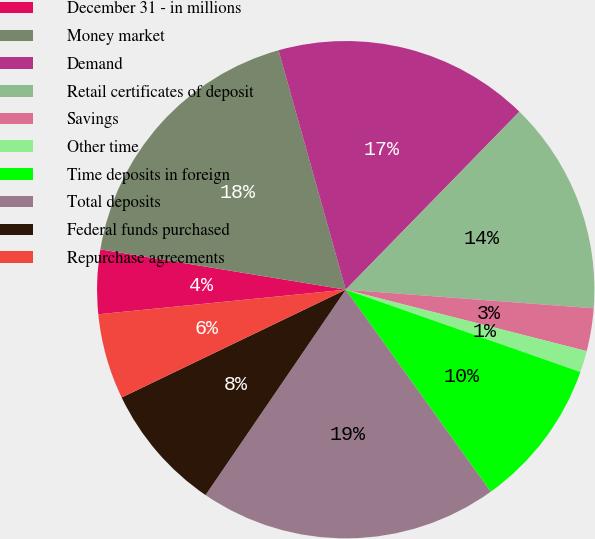Convert chart. <chart><loc_0><loc_0><loc_500><loc_500><pie_chart><fcel>December 31 - in millions<fcel>Money market<fcel>Demand<fcel>Retail certificates of deposit<fcel>Savings<fcel>Other time<fcel>Time deposits in foreign<fcel>Total deposits<fcel>Federal funds purchased<fcel>Repurchase agreements<nl><fcel>4.17%<fcel>18.05%<fcel>16.66%<fcel>13.89%<fcel>2.78%<fcel>1.4%<fcel>9.72%<fcel>19.44%<fcel>8.33%<fcel>5.56%<nl></chart> 